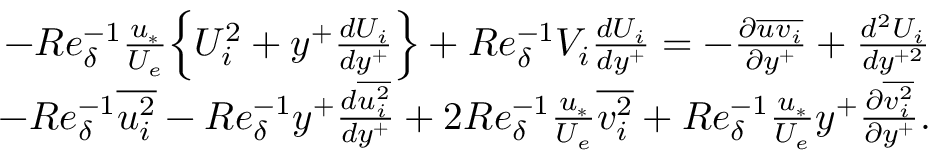Convert formula to latex. <formula><loc_0><loc_0><loc_500><loc_500>\begin{array} { r } { - R e _ { \delta } ^ { - 1 } \frac { u _ { * } } { U _ { e } } \left \{ U _ { i } ^ { 2 } + y ^ { + } \frac { d U _ { i } } { d y ^ { + } } \right \} + R e _ { \delta } ^ { - 1 } V _ { i } \frac { d U _ { i } } { d y ^ { + } } = - \frac { \partial \overline { { u v _ { i } } } } { \partial y ^ { + } } + \frac { d ^ { 2 } U _ { i } } { d y ^ { + 2 } } } \\ { - R e _ { \delta } ^ { - 1 } \overline { { u _ { i } ^ { 2 } } } - R e _ { \delta } ^ { - 1 } y ^ { + } \frac { d \overline { { u _ { i } ^ { 2 } } } } { d y ^ { + } } + 2 R e _ { \delta } ^ { - 1 } \frac { u _ { * } } { U _ { e } } \overline { { v _ { i } ^ { 2 } } } + R e _ { \delta } ^ { - 1 } \frac { u _ { * } } { U _ { e } } y ^ { + } \frac { \partial \overline { { v _ { i } ^ { 2 } } } } { \partial y ^ { + } } . } \end{array}</formula> 